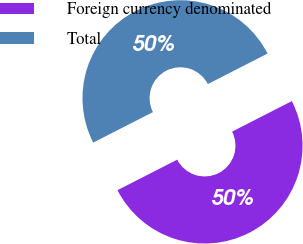Convert chart to OTSL. <chart><loc_0><loc_0><loc_500><loc_500><pie_chart><fcel>Foreign currency denominated<fcel>Total<nl><fcel>50.0%<fcel>50.0%<nl></chart> 